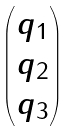Convert formula to latex. <formula><loc_0><loc_0><loc_500><loc_500>\begin{pmatrix} q _ { 1 } \\ q _ { 2 } \\ q _ { 3 } \end{pmatrix}</formula> 